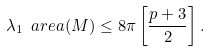Convert formula to latex. <formula><loc_0><loc_0><loc_500><loc_500>\lambda _ { 1 } \ a r e a ( M ) \leq 8 \pi \left [ \frac { p + 3 } { 2 } \right ] .</formula> 